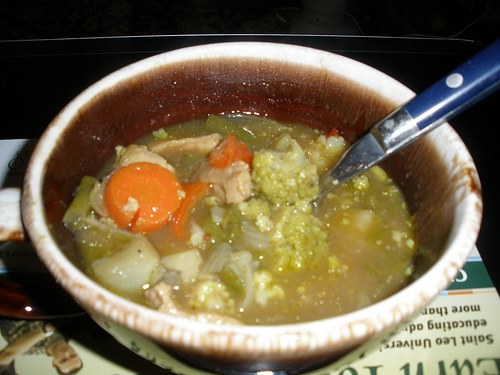How is the vegetable to the left of the onions in the center called? The vegetable to the left of the onions in the center is called a carrot. 